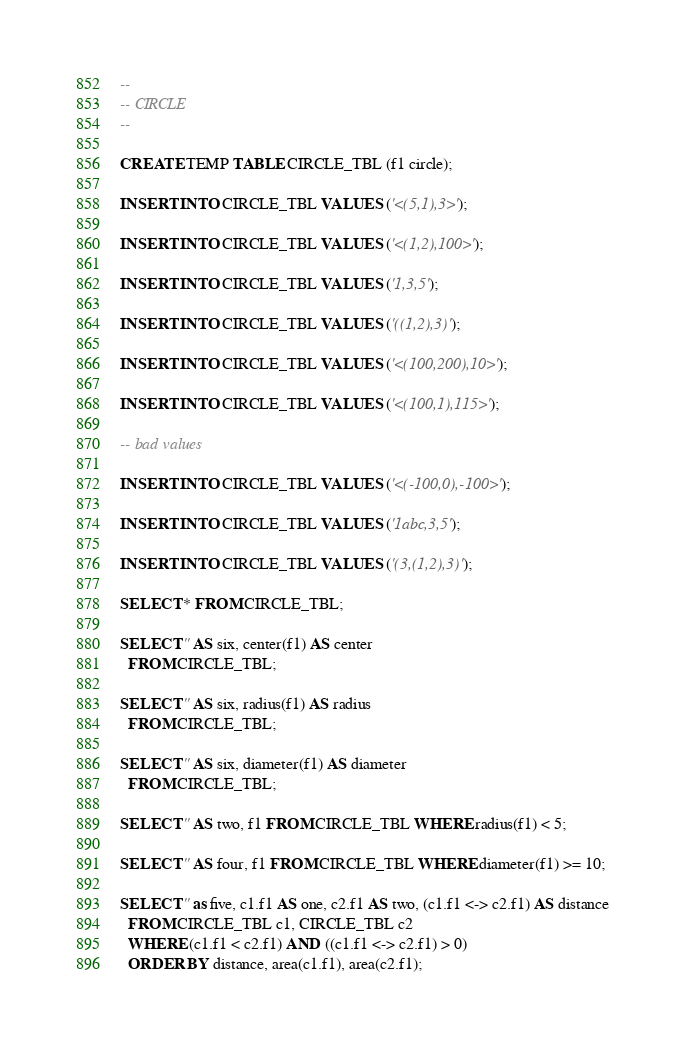Convert code to text. <code><loc_0><loc_0><loc_500><loc_500><_SQL_>--
-- CIRCLE
--

CREATE TEMP TABLE CIRCLE_TBL (f1 circle);

INSERT INTO CIRCLE_TBL VALUES ('<(5,1),3>');

INSERT INTO CIRCLE_TBL VALUES ('<(1,2),100>');

INSERT INTO CIRCLE_TBL VALUES ('1,3,5');

INSERT INTO CIRCLE_TBL VALUES ('((1,2),3)');

INSERT INTO CIRCLE_TBL VALUES ('<(100,200),10>');

INSERT INTO CIRCLE_TBL VALUES ('<(100,1),115>');

-- bad values

INSERT INTO CIRCLE_TBL VALUES ('<(-100,0),-100>');

INSERT INTO CIRCLE_TBL VALUES ('1abc,3,5');

INSERT INTO CIRCLE_TBL VALUES ('(3,(1,2),3)');

SELECT * FROM CIRCLE_TBL;

SELECT '' AS six, center(f1) AS center
  FROM CIRCLE_TBL;

SELECT '' AS six, radius(f1) AS radius
  FROM CIRCLE_TBL;

SELECT '' AS six, diameter(f1) AS diameter
  FROM CIRCLE_TBL;

SELECT '' AS two, f1 FROM CIRCLE_TBL WHERE radius(f1) < 5;

SELECT '' AS four, f1 FROM CIRCLE_TBL WHERE diameter(f1) >= 10;

SELECT '' as five, c1.f1 AS one, c2.f1 AS two, (c1.f1 <-> c2.f1) AS distance
  FROM CIRCLE_TBL c1, CIRCLE_TBL c2
  WHERE (c1.f1 < c2.f1) AND ((c1.f1 <-> c2.f1) > 0)
  ORDER BY distance, area(c1.f1), area(c2.f1);
</code> 